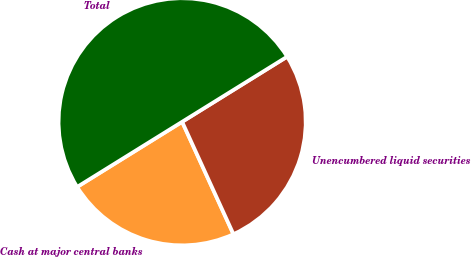Convert chart to OTSL. <chart><loc_0><loc_0><loc_500><loc_500><pie_chart><fcel>Cash at major central banks<fcel>Unencumbered liquid securities<fcel>Total<nl><fcel>22.98%<fcel>27.02%<fcel>50.0%<nl></chart> 